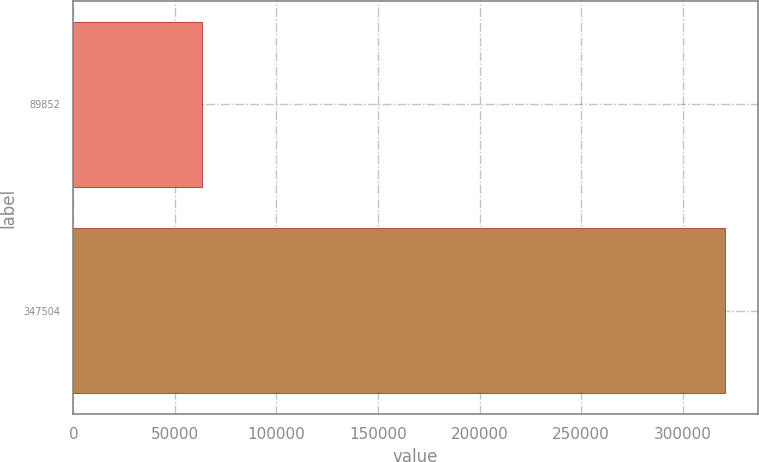Convert chart to OTSL. <chart><loc_0><loc_0><loc_500><loc_500><bar_chart><fcel>89852<fcel>347504<nl><fcel>63151<fcel>320803<nl></chart> 